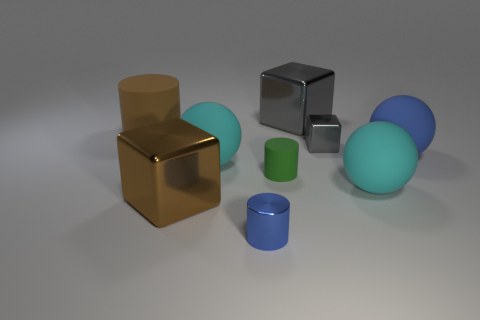Subtract all brown cubes. How many cubes are left? 2 Subtract all brown cylinders. How many cylinders are left? 2 Add 1 shiny cubes. How many objects exist? 10 Subtract 1 cubes. How many cubes are left? 2 Subtract all gray blocks. Subtract all brown balls. How many blocks are left? 1 Subtract all green blocks. How many blue balls are left? 1 Subtract all big blue matte things. Subtract all large metallic things. How many objects are left? 6 Add 7 tiny cylinders. How many tiny cylinders are left? 9 Add 6 small matte things. How many small matte things exist? 7 Subtract 0 purple blocks. How many objects are left? 9 